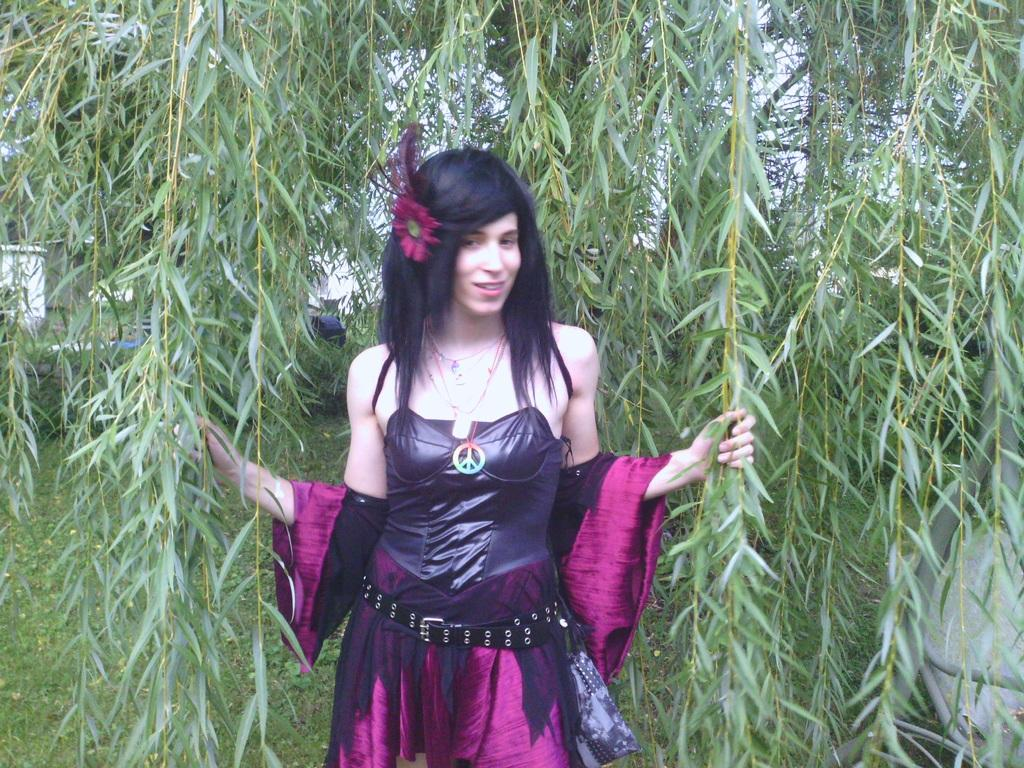Who is present in the image? There is a lady in the image. What is the lady holding in the image? The lady is holding branches of a tree. What type of ground surface is visible in the image? There is grass on the ground in the image. How many lizards can be seen crawling on the sky in the image? There are no lizards visible in the image, and the sky is not a surface where lizards can crawl. 